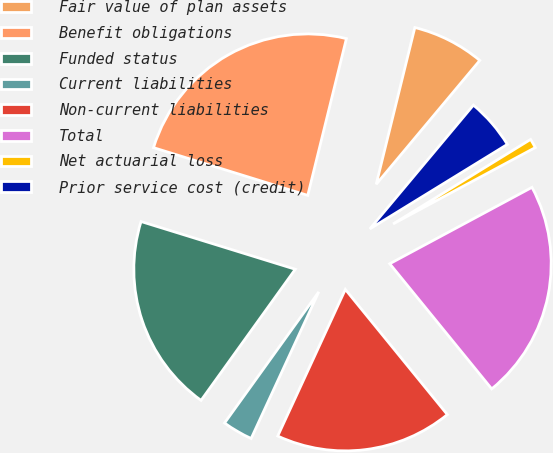Convert chart. <chart><loc_0><loc_0><loc_500><loc_500><pie_chart><fcel>Fair value of plan assets<fcel>Benefit obligations<fcel>Funded status<fcel>Current liabilities<fcel>Non-current liabilities<fcel>Total<fcel>Net actuarial loss<fcel>Prior service cost (credit)<nl><fcel>7.24%<fcel>24.07%<fcel>19.86%<fcel>3.04%<fcel>17.76%<fcel>21.96%<fcel>0.93%<fcel>5.14%<nl></chart> 